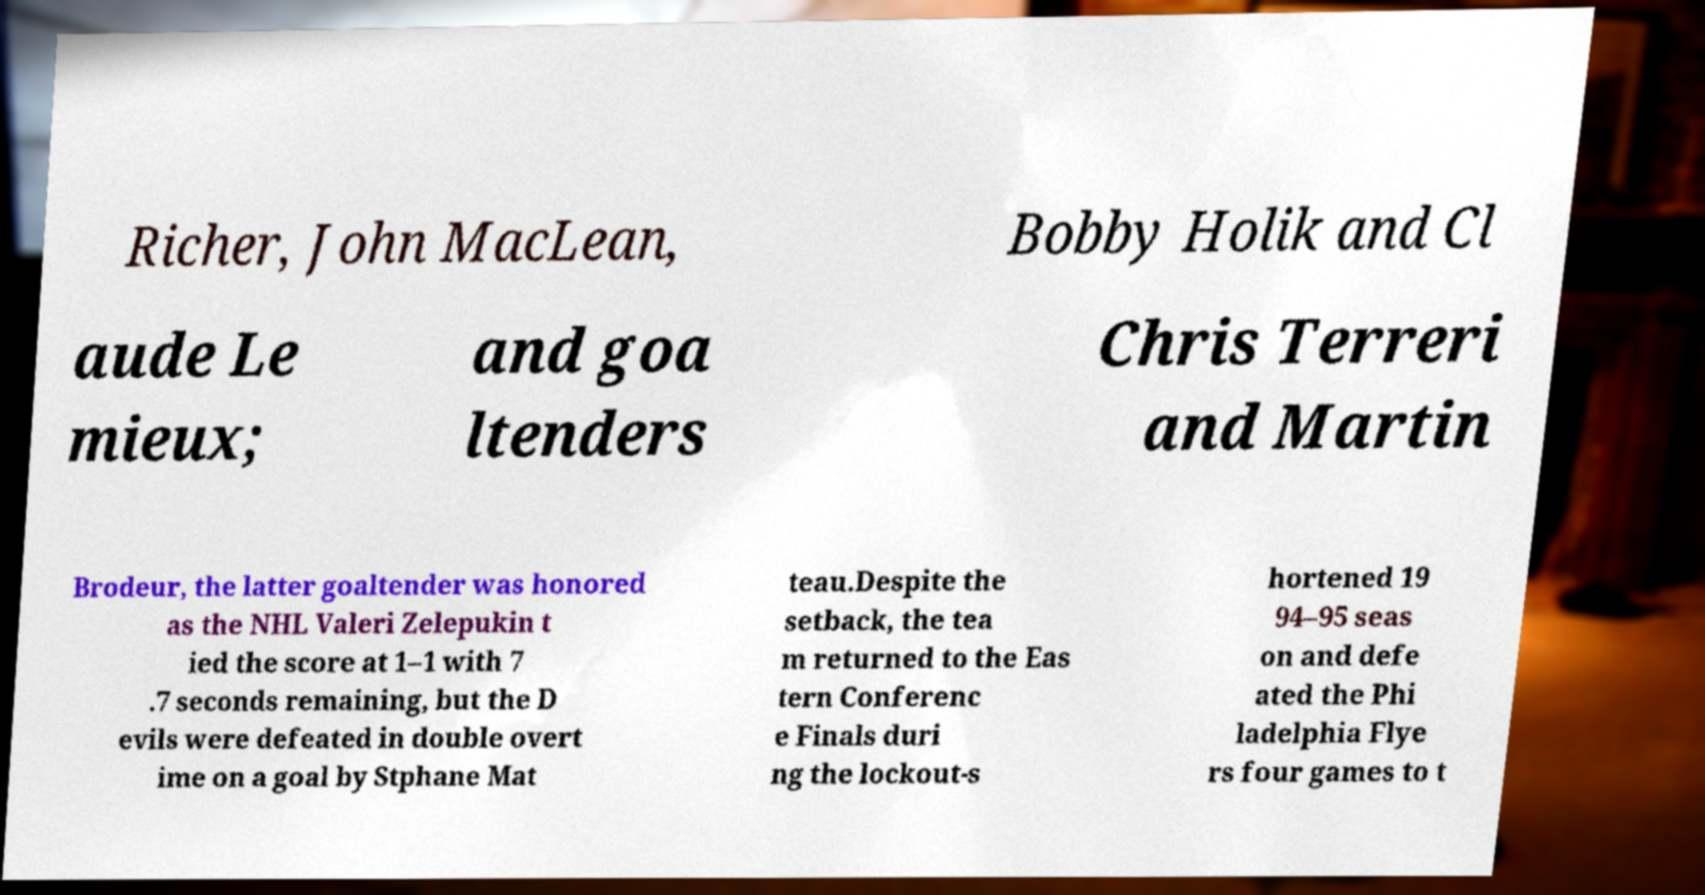Can you read and provide the text displayed in the image?This photo seems to have some interesting text. Can you extract and type it out for me? Richer, John MacLean, Bobby Holik and Cl aude Le mieux; and goa ltenders Chris Terreri and Martin Brodeur, the latter goaltender was honored as the NHL Valeri Zelepukin t ied the score at 1–1 with 7 .7 seconds remaining, but the D evils were defeated in double overt ime on a goal by Stphane Mat teau.Despite the setback, the tea m returned to the Eas tern Conferenc e Finals duri ng the lockout-s hortened 19 94–95 seas on and defe ated the Phi ladelphia Flye rs four games to t 